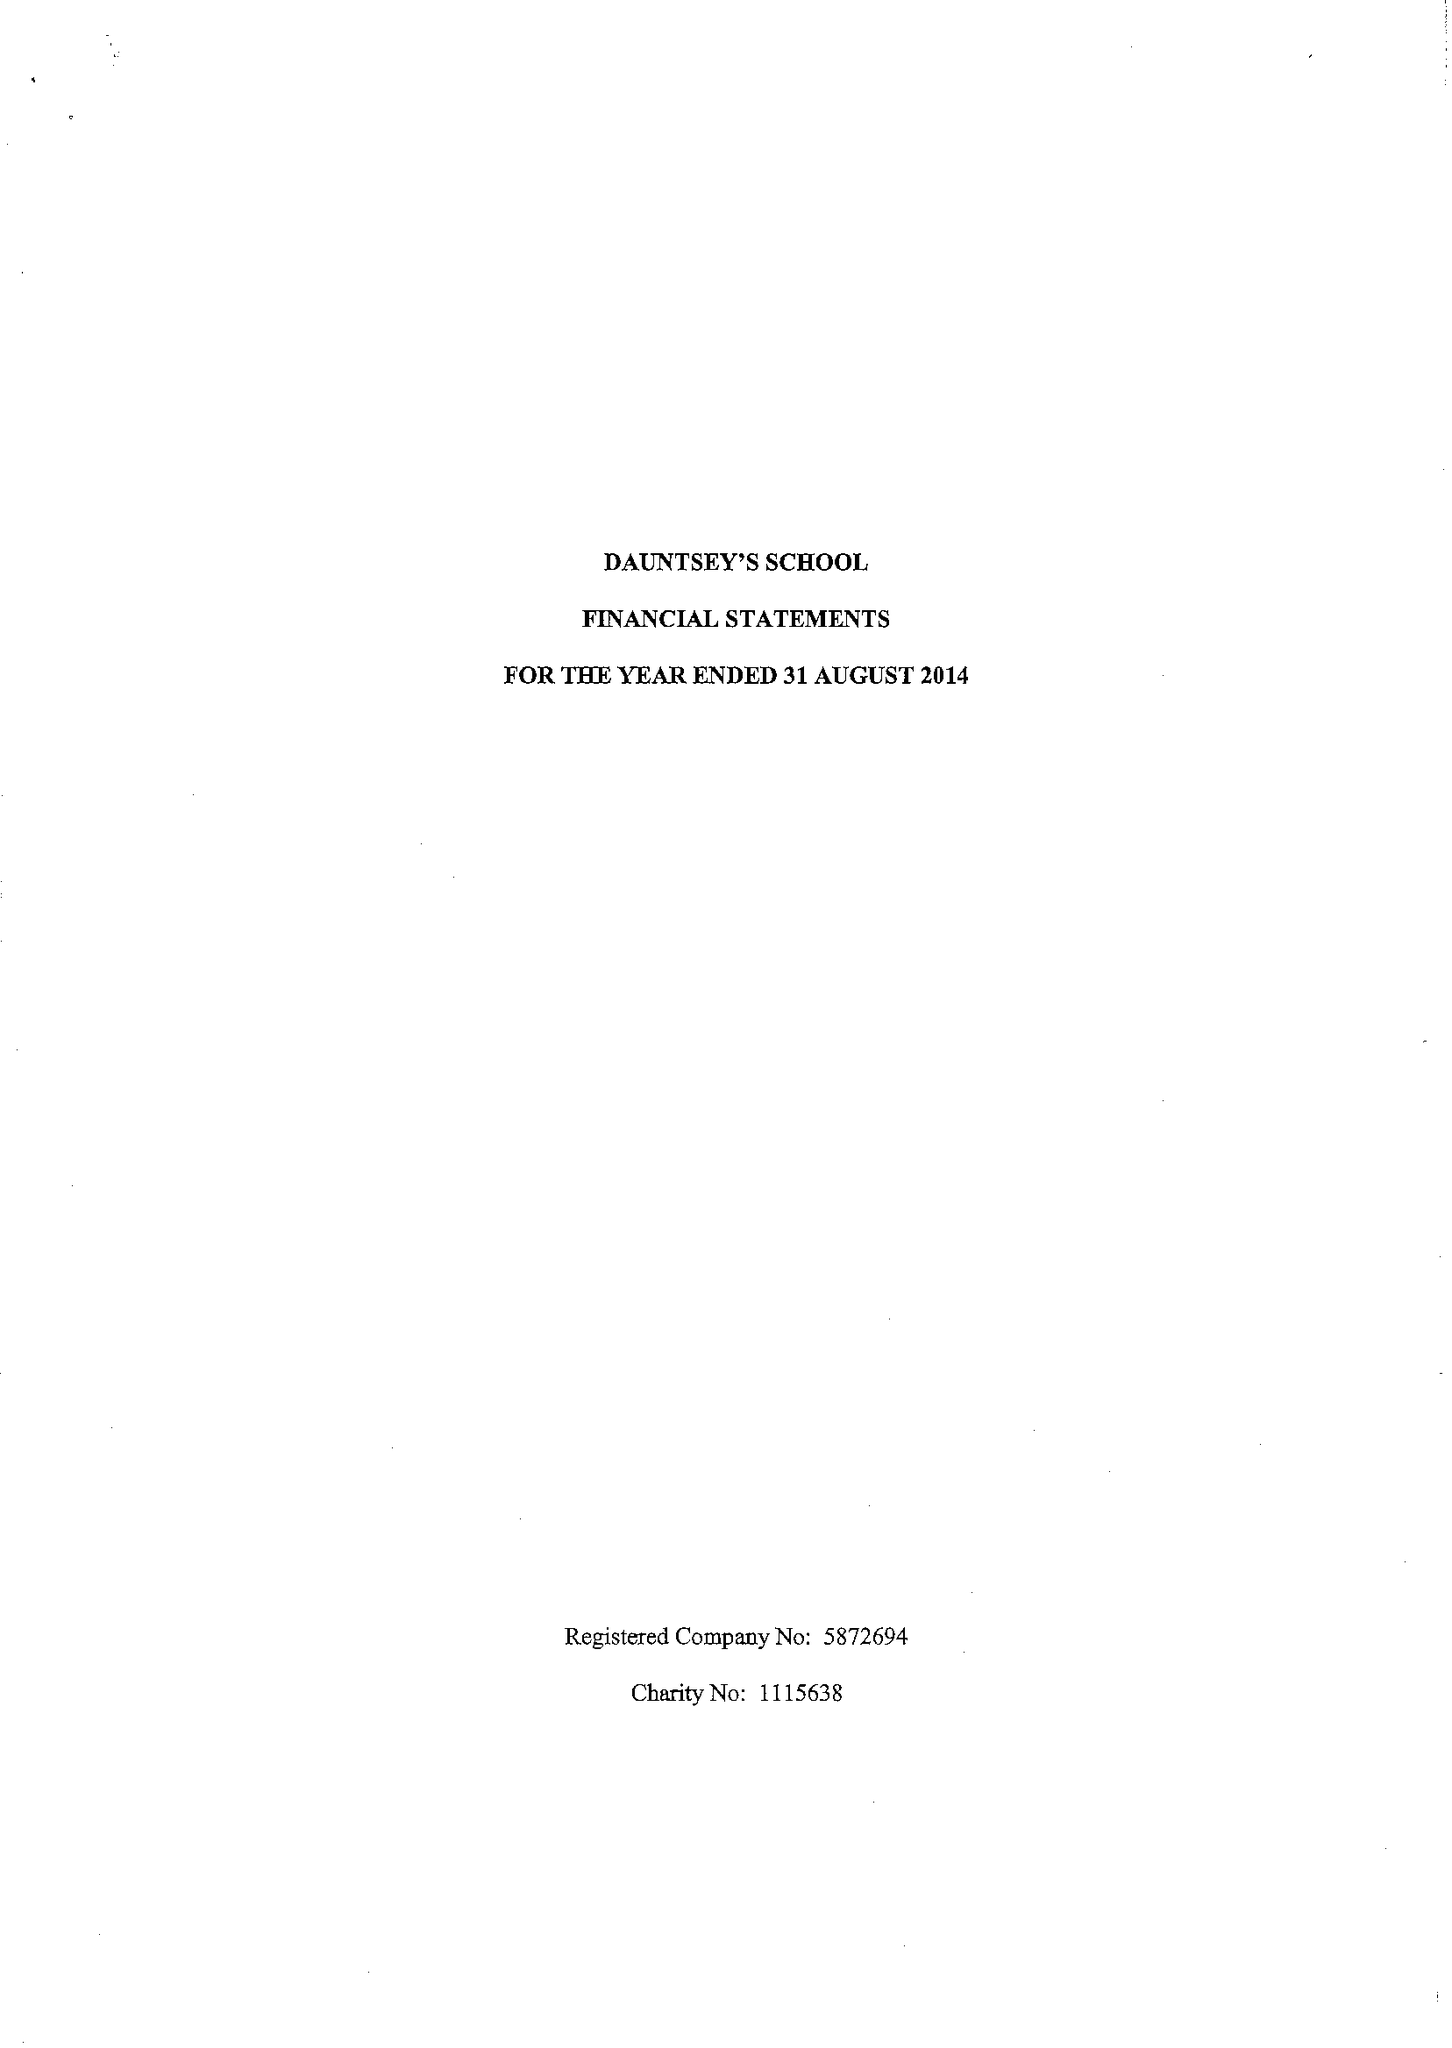What is the value for the address__street_line?
Answer the question using a single word or phrase. HIGH STREET 